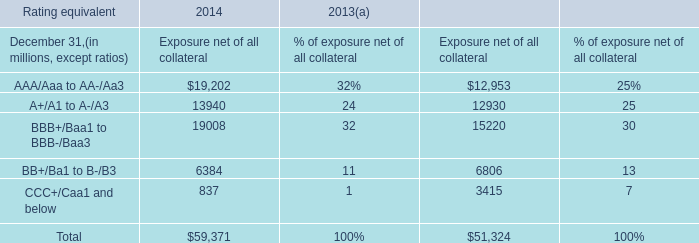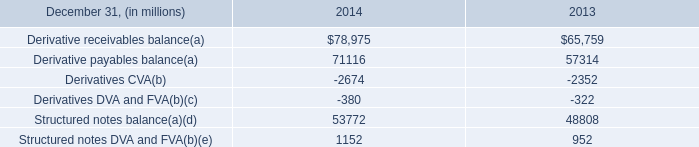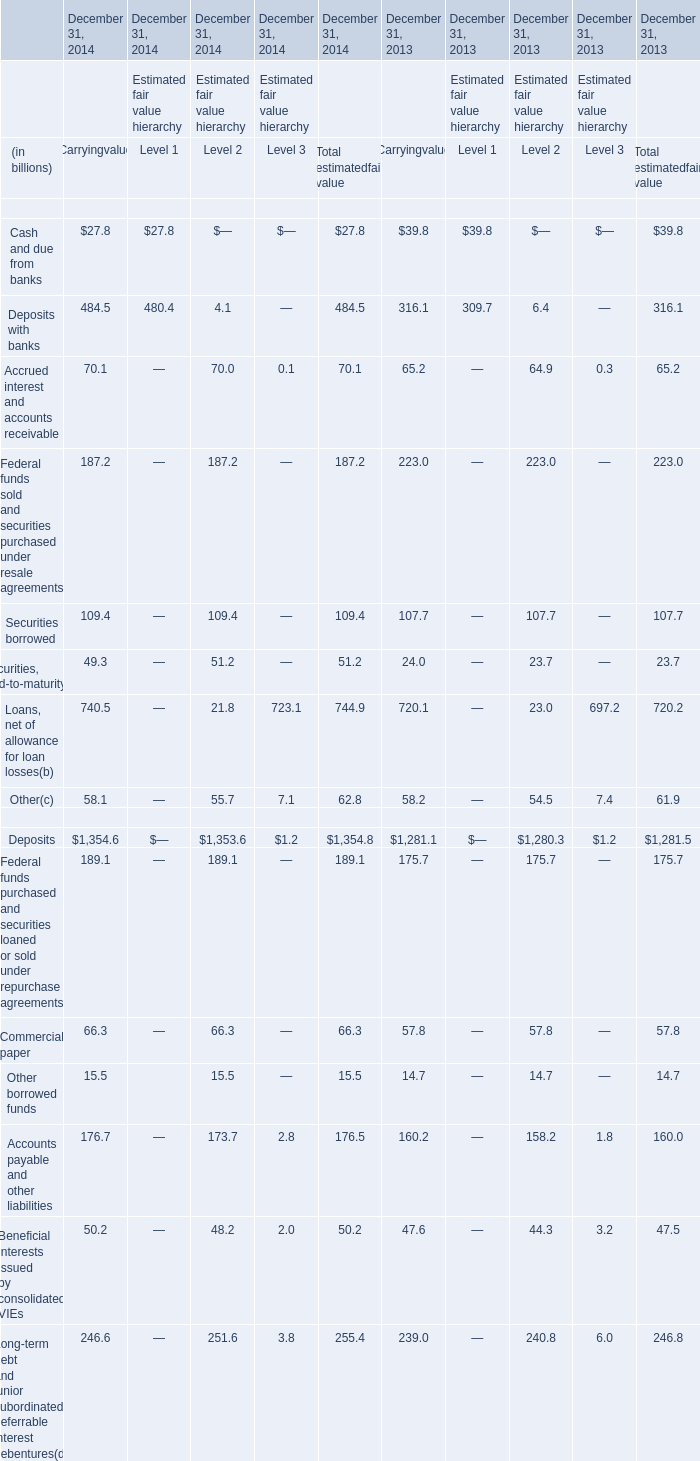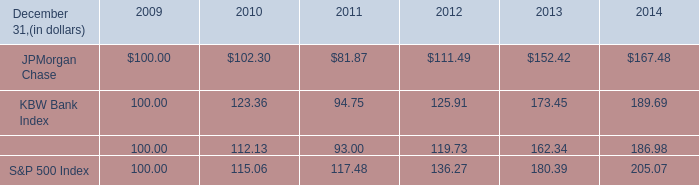what is the total return of the kbw bank index over the above refernced five year period? 
Computations: ((189.69 - 100) / 100)
Answer: 0.8969. 